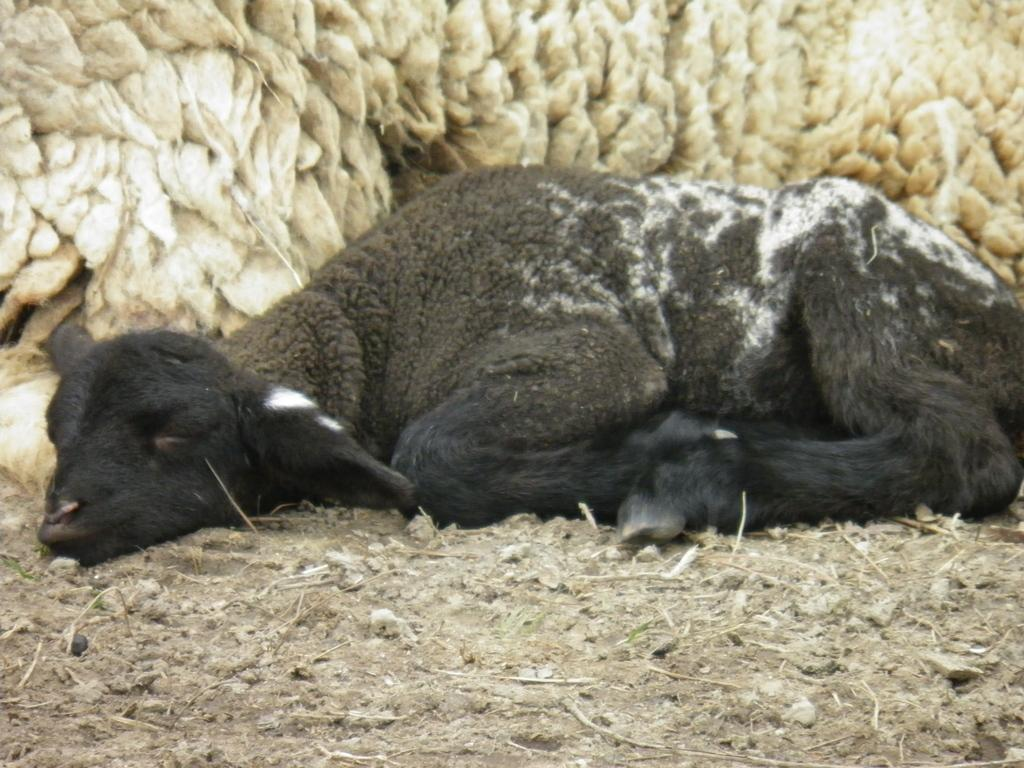What is the main subject of the image? There is an animal lying on the ground in the image. Can you describe the animal's fur? The fur of the animal is visible in the background of the image. Where is the park located in the image? There is no park present in the image; it features an animal lying on the ground. Who is the partner of the animal in the image? There is no partner mentioned or depicted in the image; it only shows an animal lying on the ground. 